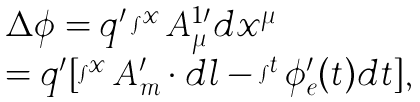Convert formula to latex. <formula><loc_0><loc_0><loc_500><loc_500>\begin{array} { l } \Delta \phi = q ^ { \prime } \int ^ { x } A _ { \mu } ^ { 1 \prime } d x ^ { \mu } \\ = q ^ { \prime } [ \int ^ { x } A _ { m } ^ { \prime } \cdot d l - \int ^ { t } \phi _ { e } ^ { \prime } ( t ) d t ] , \end{array}</formula> 